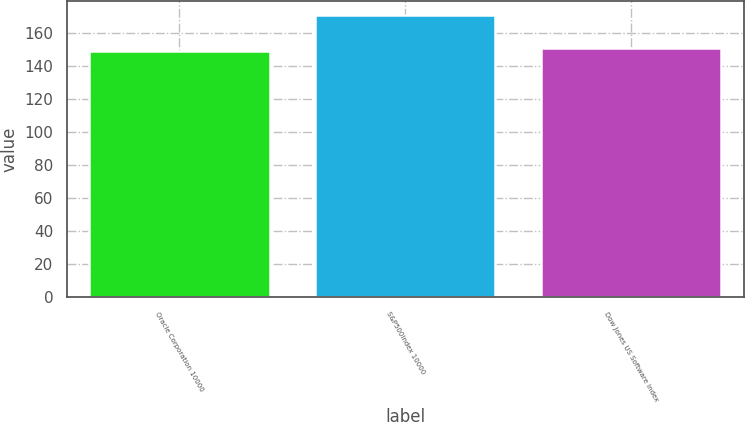<chart> <loc_0><loc_0><loc_500><loc_500><bar_chart><fcel>Oracle Corporation 10000<fcel>S&P500Index 10000<fcel>Dow Jones US Software Index<nl><fcel>148.96<fcel>170.84<fcel>151.15<nl></chart> 